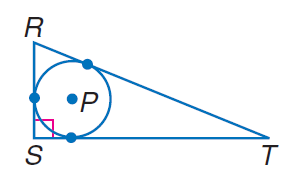Answer the mathemtical geometry problem and directly provide the correct option letter.
Question: Find the perimeter of the polygon for the given information. S T = 18, radius of \odot P = 5.
Choices: A: 58.5 B: 60 C: 70 D: 90 A 